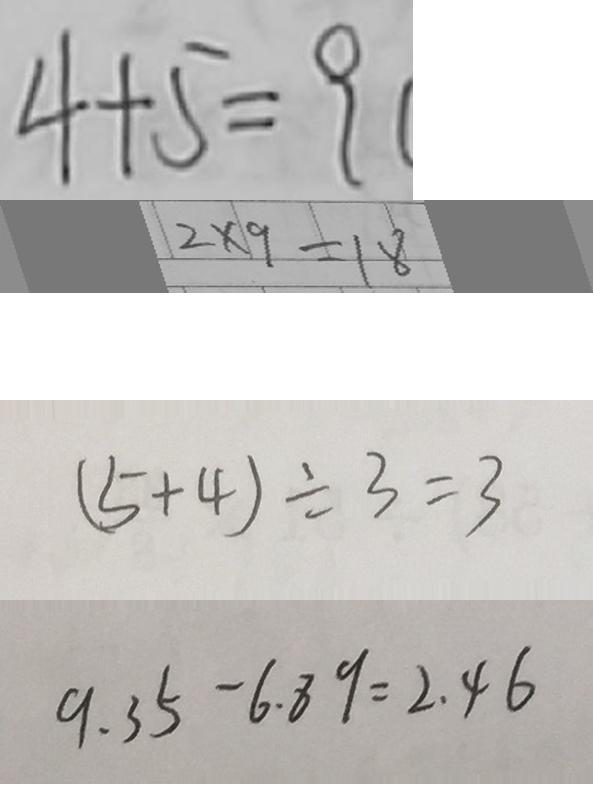<formula> <loc_0><loc_0><loc_500><loc_500>4 + 5 = 9 
 2 \times 9 = 1 8 
 ( 5 + 4 ) \div 3 = 3 
 9 . 3 5 - 6 . 8 9 = 2 . 4 6</formula> 